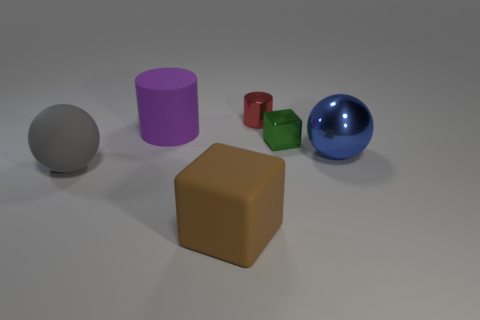There is a cylinder to the right of the large thing that is behind the blue metal sphere; is there a brown block that is behind it?
Your answer should be compact. No. The brown cube has what size?
Make the answer very short. Large. What number of things are either tiny red cylinders or purple matte things?
Provide a short and direct response. 2. What color is the big thing that is made of the same material as the small cube?
Your response must be concise. Blue. There is a large blue shiny thing right of the brown block; does it have the same shape as the large gray thing?
Offer a very short reply. Yes. How many things are big things on the left side of the purple rubber cylinder or big rubber things behind the small cube?
Your answer should be compact. 2. There is a big rubber object that is the same shape as the green shiny object; what is its color?
Give a very brief answer. Brown. Does the purple object have the same shape as the large object to the right of the big brown rubber cube?
Your answer should be very brief. No. What is the material of the tiny red object?
Ensure brevity in your answer.  Metal. There is another thing that is the same shape as the brown object; what size is it?
Keep it short and to the point. Small. 